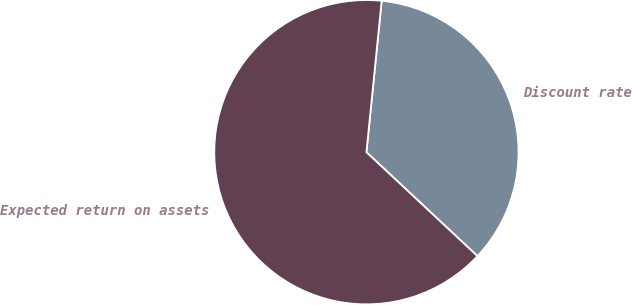<chart> <loc_0><loc_0><loc_500><loc_500><pie_chart><fcel>Discount rate<fcel>Expected return on assets<nl><fcel>35.38%<fcel>64.62%<nl></chart> 